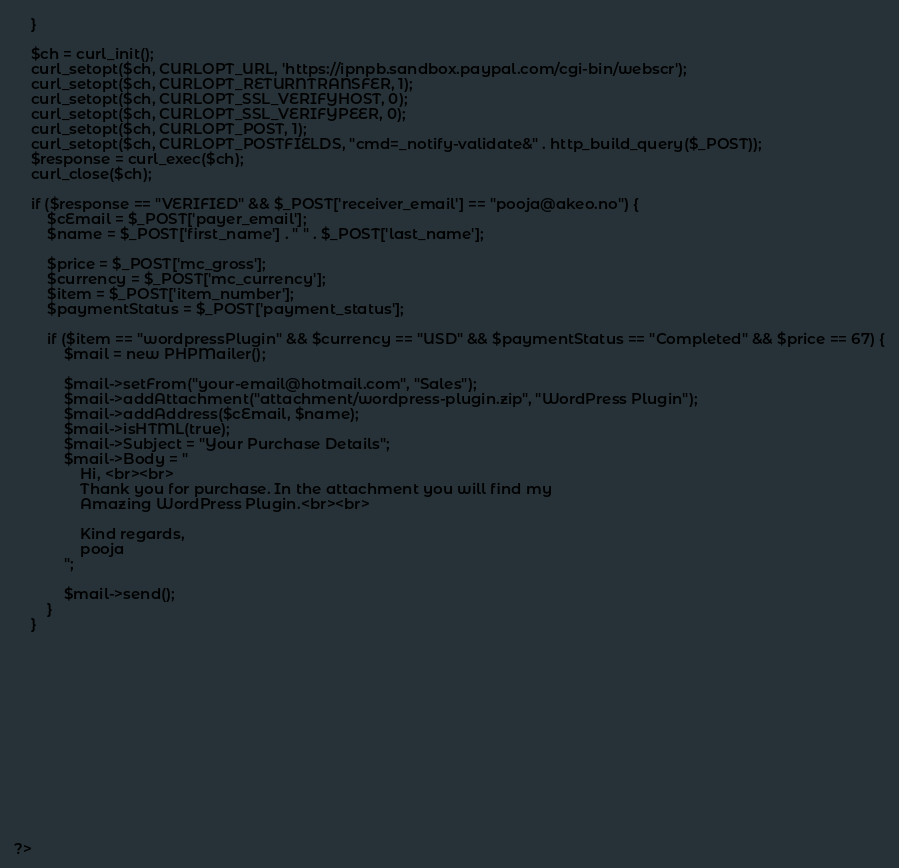Convert code to text. <code><loc_0><loc_0><loc_500><loc_500><_PHP_>	}

	$ch = curl_init();
	curl_setopt($ch, CURLOPT_URL, 'https://ipnpb.sandbox.paypal.com/cgi-bin/webscr');
	curl_setopt($ch, CURLOPT_RETURNTRANSFER, 1);
	curl_setopt($ch, CURLOPT_SSL_VERIFYHOST, 0);
	curl_setopt($ch, CURLOPT_SSL_VERIFYPEER, 0);
	curl_setopt($ch, CURLOPT_POST, 1);
	curl_setopt($ch, CURLOPT_POSTFIELDS, "cmd=_notify-validate&" . http_build_query($_POST));
	$response = curl_exec($ch);
	curl_close($ch);

	if ($response == "VERIFIED" && $_POST['receiver_email'] == "pooja@akeo.no") {
		$cEmail = $_POST['payer_email'];
		$name = $_POST['first_name'] . " " . $_POST['last_name'];

		$price = $_POST['mc_gross'];
		$currency = $_POST['mc_currency'];
		$item = $_POST['item_number'];
		$paymentStatus = $_POST['payment_status'];

		if ($item == "wordpressPlugin" && $currency == "USD" && $paymentStatus == "Completed" && $price == 67) {
			$mail = new PHPMailer();

			$mail->setFrom("your-email@hotmail.com", "Sales");
			$mail->addAttachment("attachment/wordpress-plugin.zip", "WordPress Plugin");
			$mail->addAddress($cEmail, $name);
			$mail->isHTML(true);
			$mail->Subject = "Your Purchase Details";
			$mail->Body = "
				Hi, <br><br>
				Thank you for purchase. In the attachment you will find my
				Amazing WordPress Plugin.<br><br>
				
				Kind regards,
				pooja
			";

			$mail->send();
		}
	}














?>
</code> 